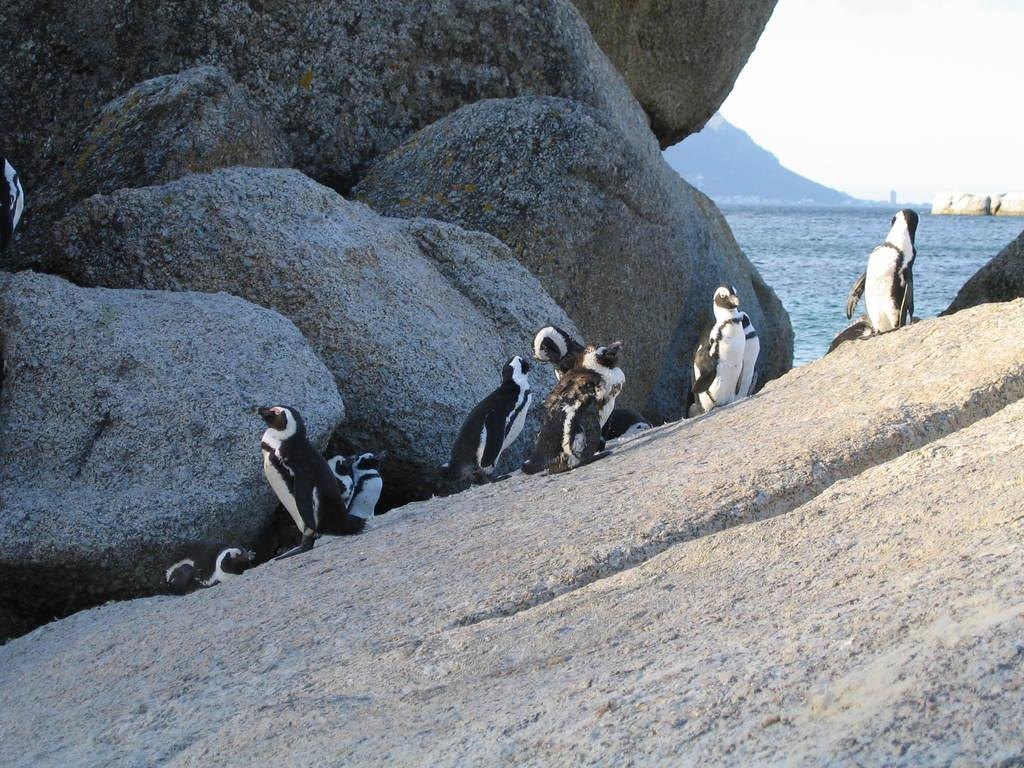What animals are on a rock in the image? There are penguins on a rock in the image. What type of terrain is visible in the background of the image? There are rocks and mountains visible in the background of the image. What natural element is visible in the background of the image? There is water visible in the background of the image. What part of the sky is visible in the background of the image? The sky is visible in the background of the image. What type of fowl is performing on the stage in the image? There is no stage or fowl performing in the image; it features penguins on a rock with a background of rocks, mountains, water, and sky. 